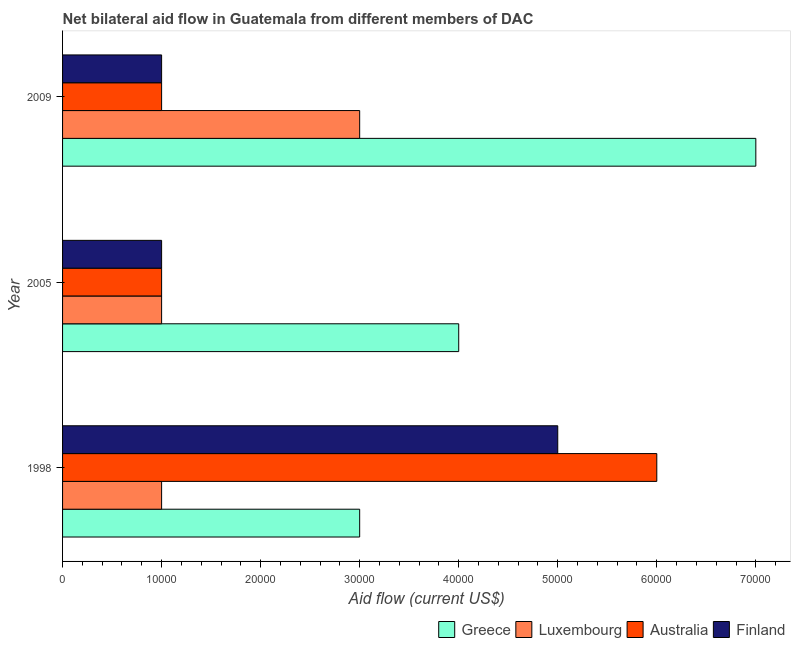How many different coloured bars are there?
Your answer should be compact. 4. Are the number of bars per tick equal to the number of legend labels?
Make the answer very short. Yes. How many bars are there on the 2nd tick from the top?
Provide a succinct answer. 4. How many bars are there on the 2nd tick from the bottom?
Ensure brevity in your answer.  4. What is the amount of aid given by australia in 1998?
Ensure brevity in your answer.  6.00e+04. Across all years, what is the maximum amount of aid given by luxembourg?
Provide a succinct answer. 3.00e+04. Across all years, what is the minimum amount of aid given by luxembourg?
Your response must be concise. 10000. In which year was the amount of aid given by finland maximum?
Give a very brief answer. 1998. In which year was the amount of aid given by greece minimum?
Your response must be concise. 1998. What is the total amount of aid given by finland in the graph?
Your answer should be very brief. 7.00e+04. What is the difference between the amount of aid given by luxembourg in 1998 and that in 2009?
Your response must be concise. -2.00e+04. What is the difference between the amount of aid given by luxembourg in 2005 and the amount of aid given by greece in 1998?
Your answer should be very brief. -2.00e+04. What is the average amount of aid given by luxembourg per year?
Ensure brevity in your answer.  1.67e+04. In how many years, is the amount of aid given by luxembourg greater than 6000 US$?
Make the answer very short. 3. Is the amount of aid given by luxembourg in 1998 less than that in 2009?
Keep it short and to the point. Yes. What is the difference between the highest and the lowest amount of aid given by greece?
Ensure brevity in your answer.  4.00e+04. Is the sum of the amount of aid given by finland in 2005 and 2009 greater than the maximum amount of aid given by australia across all years?
Provide a succinct answer. No. Is it the case that in every year, the sum of the amount of aid given by finland and amount of aid given by greece is greater than the sum of amount of aid given by australia and amount of aid given by luxembourg?
Your answer should be compact. Yes. What does the 3rd bar from the top in 2005 represents?
Offer a very short reply. Luxembourg. How many bars are there?
Offer a terse response. 12. What is the difference between two consecutive major ticks on the X-axis?
Give a very brief answer. 10000. Does the graph contain grids?
Your response must be concise. No. Where does the legend appear in the graph?
Offer a terse response. Bottom right. How many legend labels are there?
Your response must be concise. 4. How are the legend labels stacked?
Provide a succinct answer. Horizontal. What is the title of the graph?
Offer a terse response. Net bilateral aid flow in Guatemala from different members of DAC. Does "Quality Certification" appear as one of the legend labels in the graph?
Keep it short and to the point. No. What is the label or title of the Y-axis?
Give a very brief answer. Year. What is the Aid flow (current US$) in Greece in 1998?
Ensure brevity in your answer.  3.00e+04. What is the Aid flow (current US$) in Australia in 1998?
Offer a very short reply. 6.00e+04. What is the Aid flow (current US$) of Finland in 1998?
Your answer should be very brief. 5.00e+04. What is the Aid flow (current US$) in Greece in 2005?
Your response must be concise. 4.00e+04. What is the Aid flow (current US$) in Greece in 2009?
Make the answer very short. 7.00e+04. What is the Aid flow (current US$) of Luxembourg in 2009?
Make the answer very short. 3.00e+04. What is the Aid flow (current US$) of Australia in 2009?
Give a very brief answer. 10000. What is the Aid flow (current US$) in Finland in 2009?
Your answer should be compact. 10000. Across all years, what is the maximum Aid flow (current US$) in Australia?
Your answer should be very brief. 6.00e+04. Across all years, what is the minimum Aid flow (current US$) of Luxembourg?
Provide a succinct answer. 10000. Across all years, what is the minimum Aid flow (current US$) in Australia?
Your answer should be compact. 10000. Across all years, what is the minimum Aid flow (current US$) in Finland?
Give a very brief answer. 10000. What is the total Aid flow (current US$) in Luxembourg in the graph?
Keep it short and to the point. 5.00e+04. What is the total Aid flow (current US$) in Finland in the graph?
Give a very brief answer. 7.00e+04. What is the difference between the Aid flow (current US$) of Greece in 1998 and that in 2005?
Offer a terse response. -10000. What is the difference between the Aid flow (current US$) of Australia in 1998 and that in 2005?
Provide a succinct answer. 5.00e+04. What is the difference between the Aid flow (current US$) of Greece in 1998 and that in 2009?
Your answer should be compact. -4.00e+04. What is the difference between the Aid flow (current US$) in Luxembourg in 1998 and that in 2009?
Ensure brevity in your answer.  -2.00e+04. What is the difference between the Aid flow (current US$) in Greece in 2005 and that in 2009?
Ensure brevity in your answer.  -3.00e+04. What is the difference between the Aid flow (current US$) of Australia in 2005 and that in 2009?
Provide a short and direct response. 0. What is the difference between the Aid flow (current US$) in Finland in 2005 and that in 2009?
Provide a short and direct response. 0. What is the difference between the Aid flow (current US$) of Greece in 1998 and the Aid flow (current US$) of Luxembourg in 2005?
Offer a terse response. 2.00e+04. What is the difference between the Aid flow (current US$) of Greece in 1998 and the Aid flow (current US$) of Australia in 2005?
Offer a terse response. 2.00e+04. What is the difference between the Aid flow (current US$) of Luxembourg in 1998 and the Aid flow (current US$) of Australia in 2005?
Keep it short and to the point. 0. What is the difference between the Aid flow (current US$) in Australia in 1998 and the Aid flow (current US$) in Finland in 2005?
Keep it short and to the point. 5.00e+04. What is the difference between the Aid flow (current US$) of Greece in 1998 and the Aid flow (current US$) of Finland in 2009?
Offer a terse response. 2.00e+04. What is the difference between the Aid flow (current US$) of Luxembourg in 1998 and the Aid flow (current US$) of Australia in 2009?
Provide a short and direct response. 0. What is the average Aid flow (current US$) of Greece per year?
Keep it short and to the point. 4.67e+04. What is the average Aid flow (current US$) in Luxembourg per year?
Your response must be concise. 1.67e+04. What is the average Aid flow (current US$) of Australia per year?
Your answer should be compact. 2.67e+04. What is the average Aid flow (current US$) in Finland per year?
Provide a short and direct response. 2.33e+04. In the year 1998, what is the difference between the Aid flow (current US$) of Greece and Aid flow (current US$) of Luxembourg?
Your answer should be compact. 2.00e+04. In the year 1998, what is the difference between the Aid flow (current US$) of Greece and Aid flow (current US$) of Finland?
Your response must be concise. -2.00e+04. In the year 1998, what is the difference between the Aid flow (current US$) of Australia and Aid flow (current US$) of Finland?
Your answer should be compact. 10000. In the year 2005, what is the difference between the Aid flow (current US$) in Greece and Aid flow (current US$) in Luxembourg?
Your answer should be compact. 3.00e+04. In the year 2005, what is the difference between the Aid flow (current US$) in Greece and Aid flow (current US$) in Australia?
Offer a very short reply. 3.00e+04. In the year 2005, what is the difference between the Aid flow (current US$) of Greece and Aid flow (current US$) of Finland?
Provide a short and direct response. 3.00e+04. In the year 2005, what is the difference between the Aid flow (current US$) of Luxembourg and Aid flow (current US$) of Australia?
Your answer should be compact. 0. In the year 2005, what is the difference between the Aid flow (current US$) in Luxembourg and Aid flow (current US$) in Finland?
Offer a very short reply. 0. In the year 2005, what is the difference between the Aid flow (current US$) of Australia and Aid flow (current US$) of Finland?
Offer a very short reply. 0. In the year 2009, what is the difference between the Aid flow (current US$) in Greece and Aid flow (current US$) in Luxembourg?
Give a very brief answer. 4.00e+04. In the year 2009, what is the difference between the Aid flow (current US$) in Luxembourg and Aid flow (current US$) in Finland?
Make the answer very short. 2.00e+04. What is the ratio of the Aid flow (current US$) of Greece in 1998 to that in 2005?
Make the answer very short. 0.75. What is the ratio of the Aid flow (current US$) in Finland in 1998 to that in 2005?
Offer a very short reply. 5. What is the ratio of the Aid flow (current US$) in Greece in 1998 to that in 2009?
Your response must be concise. 0.43. What is the ratio of the Aid flow (current US$) in Luxembourg in 1998 to that in 2009?
Offer a very short reply. 0.33. What is the ratio of the Aid flow (current US$) in Australia in 1998 to that in 2009?
Provide a succinct answer. 6. What is the ratio of the Aid flow (current US$) in Finland in 1998 to that in 2009?
Offer a terse response. 5. What is the difference between the highest and the second highest Aid flow (current US$) of Luxembourg?
Offer a terse response. 2.00e+04. What is the difference between the highest and the second highest Aid flow (current US$) of Australia?
Make the answer very short. 5.00e+04. What is the difference between the highest and the second highest Aid flow (current US$) of Finland?
Keep it short and to the point. 4.00e+04. What is the difference between the highest and the lowest Aid flow (current US$) of Luxembourg?
Give a very brief answer. 2.00e+04. What is the difference between the highest and the lowest Aid flow (current US$) in Australia?
Your response must be concise. 5.00e+04. 